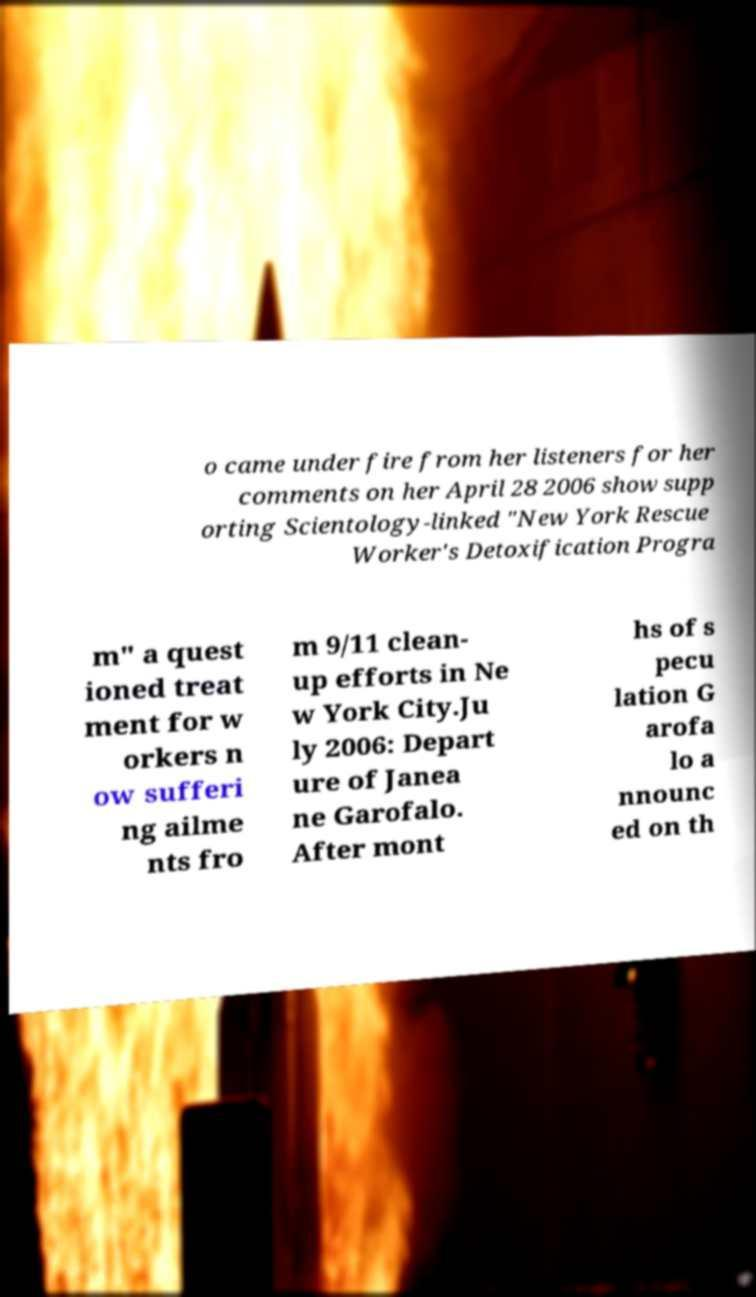Please identify and transcribe the text found in this image. o came under fire from her listeners for her comments on her April 28 2006 show supp orting Scientology-linked "New York Rescue Worker's Detoxification Progra m" a quest ioned treat ment for w orkers n ow sufferi ng ailme nts fro m 9/11 clean- up efforts in Ne w York City.Ju ly 2006: Depart ure of Janea ne Garofalo. After mont hs of s pecu lation G arofa lo a nnounc ed on th 